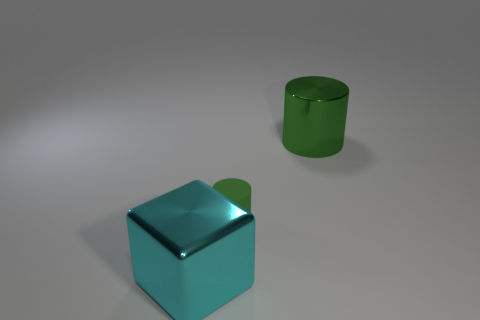What shape is the big shiny object left of the large shiny thing that is on the right side of the big cyan thing?
Give a very brief answer. Cube. What number of cyan cubes are the same size as the green metal cylinder?
Your answer should be very brief. 1. Are there any small blue metallic spheres?
Keep it short and to the point. No. Is there any other thing that is the same color as the matte object?
Provide a succinct answer. Yes. The green object that is made of the same material as the large cube is what shape?
Make the answer very short. Cylinder. There is a big thing behind the green thing on the left side of the big thing behind the large cyan thing; what is its color?
Ensure brevity in your answer.  Green. Are there the same number of big green metallic things in front of the cube and tiny gray cubes?
Make the answer very short. Yes. Is there anything else that has the same material as the tiny green cylinder?
Give a very brief answer. No. There is a shiny cylinder; is it the same color as the cylinder that is in front of the large shiny cylinder?
Give a very brief answer. Yes. Are there any metal cylinders that are behind the metallic thing that is on the left side of the green cylinder that is to the right of the small object?
Offer a very short reply. Yes. 